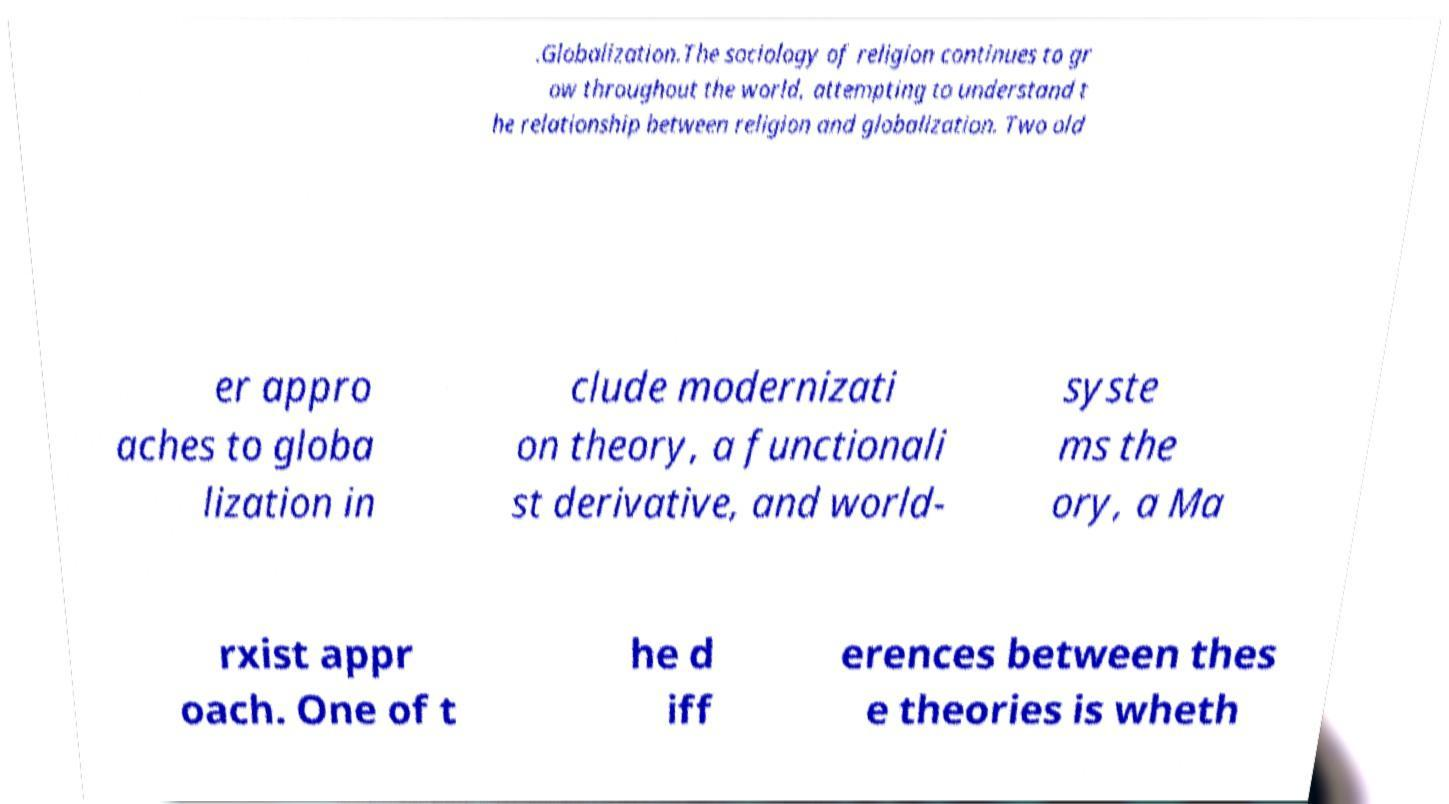Can you accurately transcribe the text from the provided image for me? .Globalization.The sociology of religion continues to gr ow throughout the world, attempting to understand t he relationship between religion and globalization. Two old er appro aches to globa lization in clude modernizati on theory, a functionali st derivative, and world- syste ms the ory, a Ma rxist appr oach. One of t he d iff erences between thes e theories is wheth 